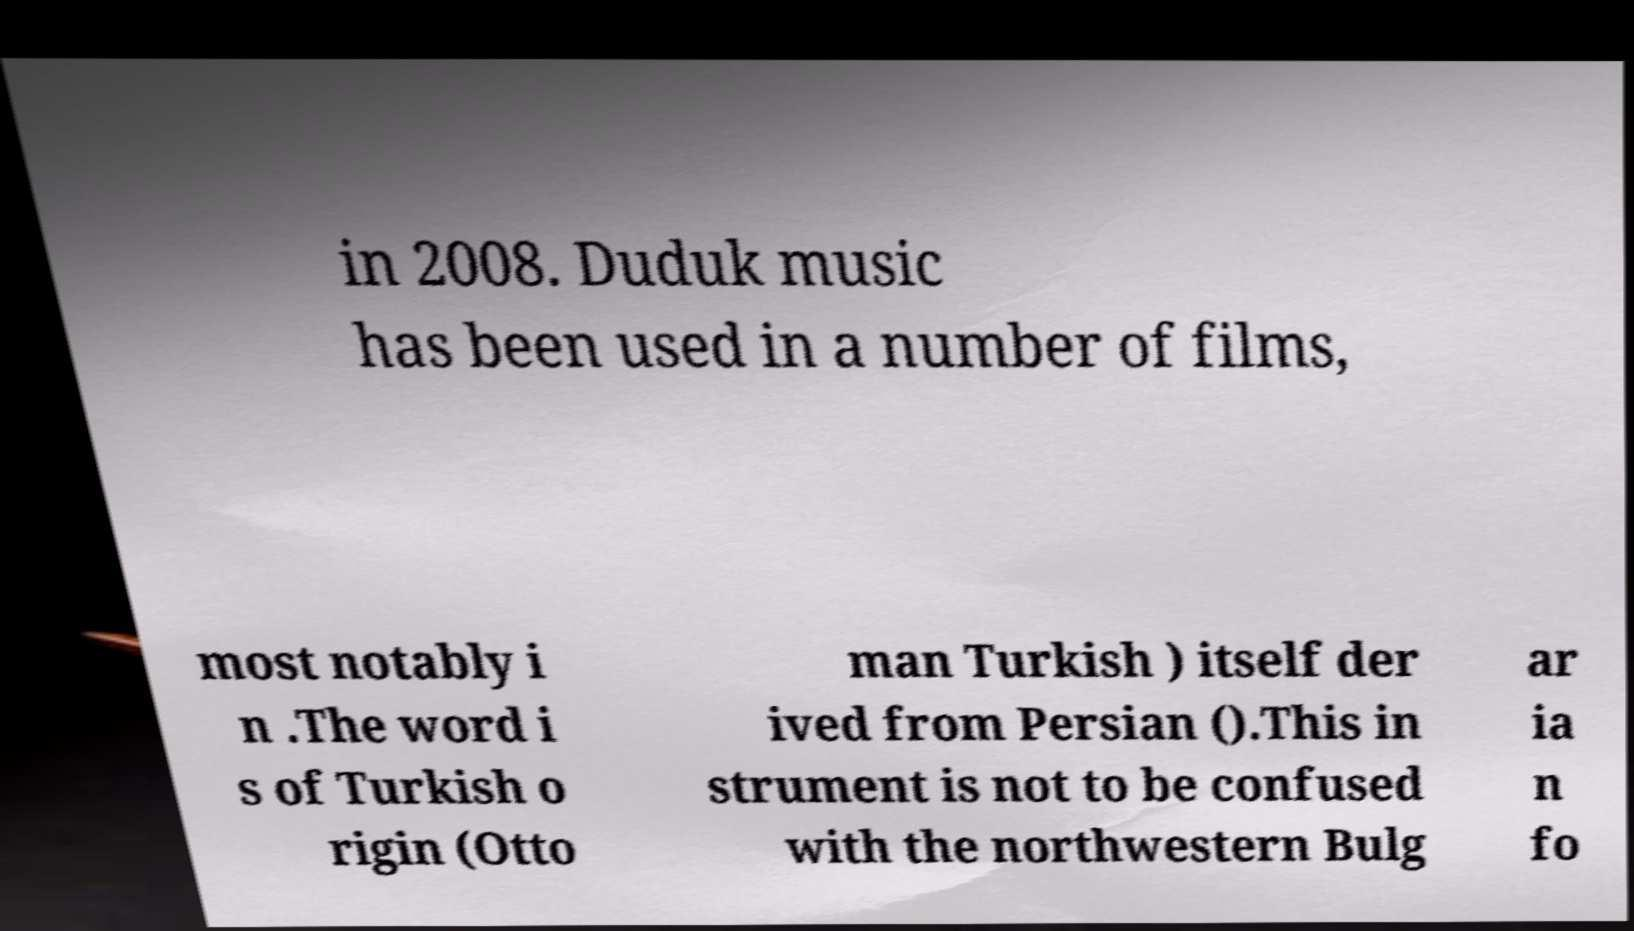Can you read and provide the text displayed in the image?This photo seems to have some interesting text. Can you extract and type it out for me? in 2008. Duduk music has been used in a number of films, most notably i n .The word i s of Turkish o rigin (Otto man Turkish ) itself der ived from Persian ().This in strument is not to be confused with the northwestern Bulg ar ia n fo 